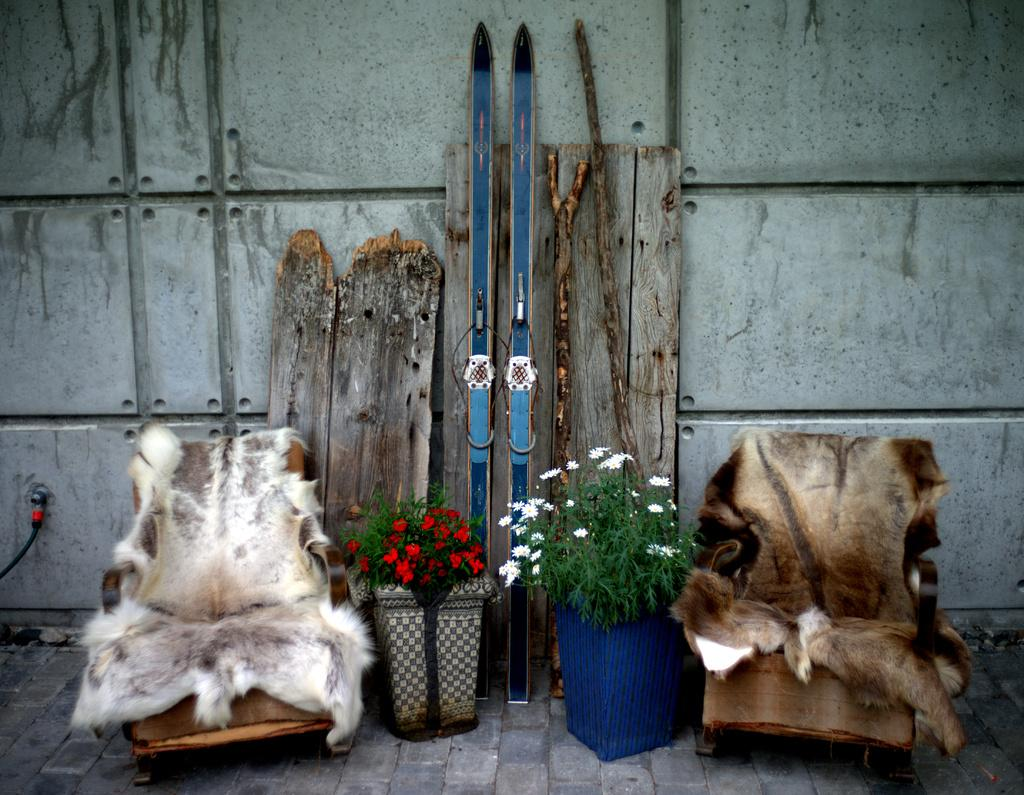What type of furniture is present in the image? There are chairs in the image. What type of decorative items can be seen in the image? There are house plants and flowers in the image. What type of sports equipment is visible in the image? There are skis in the image. What type of materials are used for the items in the image? There are wooden sticks and wooden planks in the image. What type of structure is present in the image? There is a wall in the image. How many geese are sitting on the button in the image? There are no geese or buttons present in the image. What type of brake system is used for the wooden planks in the image? There is no brake system present in the image; it features wooden planks and other items. 